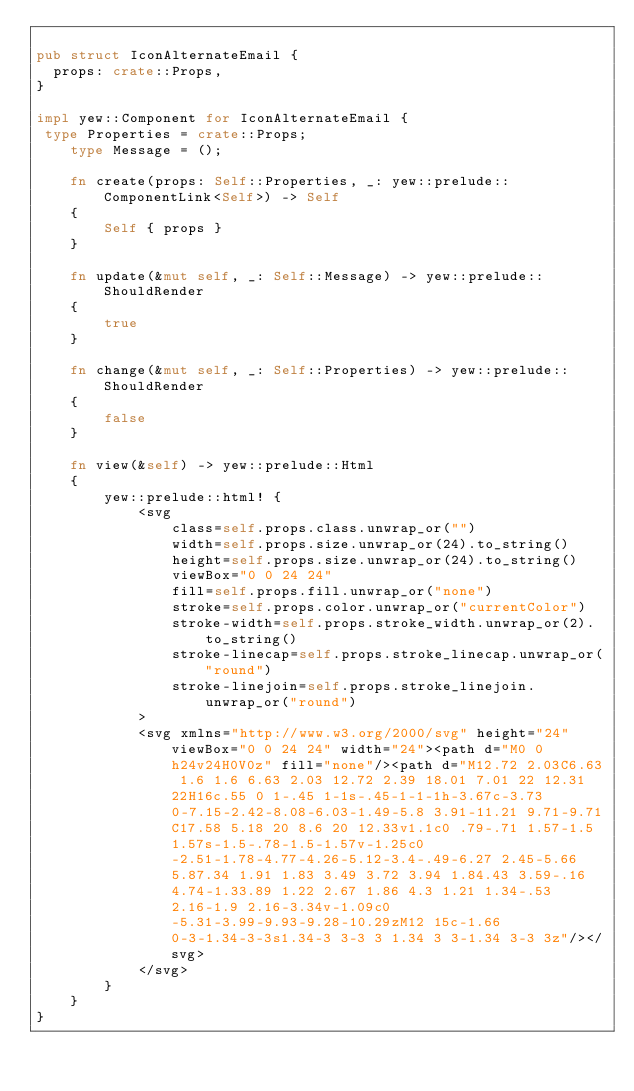Convert code to text. <code><loc_0><loc_0><loc_500><loc_500><_Rust_>
pub struct IconAlternateEmail {
  props: crate::Props,
}

impl yew::Component for IconAlternateEmail {
 type Properties = crate::Props;
    type Message = ();

    fn create(props: Self::Properties, _: yew::prelude::ComponentLink<Self>) -> Self
    {
        Self { props }
    }

    fn update(&mut self, _: Self::Message) -> yew::prelude::ShouldRender
    {
        true
    }

    fn change(&mut self, _: Self::Properties) -> yew::prelude::ShouldRender
    {
        false
    }

    fn view(&self) -> yew::prelude::Html
    {
        yew::prelude::html! {
            <svg
                class=self.props.class.unwrap_or("")
                width=self.props.size.unwrap_or(24).to_string()
                height=self.props.size.unwrap_or(24).to_string()
                viewBox="0 0 24 24"
                fill=self.props.fill.unwrap_or("none")
                stroke=self.props.color.unwrap_or("currentColor")
                stroke-width=self.props.stroke_width.unwrap_or(2).to_string()
                stroke-linecap=self.props.stroke_linecap.unwrap_or("round")
                stroke-linejoin=self.props.stroke_linejoin.unwrap_or("round")
            >
            <svg xmlns="http://www.w3.org/2000/svg" height="24" viewBox="0 0 24 24" width="24"><path d="M0 0h24v24H0V0z" fill="none"/><path d="M12.72 2.03C6.63 1.6 1.6 6.63 2.03 12.72 2.39 18.01 7.01 22 12.31 22H16c.55 0 1-.45 1-1s-.45-1-1-1h-3.67c-3.73 0-7.15-2.42-8.08-6.03-1.49-5.8 3.91-11.21 9.71-9.71C17.58 5.18 20 8.6 20 12.33v1.1c0 .79-.71 1.57-1.5 1.57s-1.5-.78-1.5-1.57v-1.25c0-2.51-1.78-4.77-4.26-5.12-3.4-.49-6.27 2.45-5.66 5.87.34 1.91 1.83 3.49 3.72 3.94 1.84.43 3.59-.16 4.74-1.33.89 1.22 2.67 1.86 4.3 1.21 1.34-.53 2.16-1.9 2.16-3.34v-1.09c0-5.31-3.99-9.93-9.28-10.29zM12 15c-1.66 0-3-1.34-3-3s1.34-3 3-3 3 1.34 3 3-1.34 3-3 3z"/></svg>
            </svg>
        }
    }
}


</code> 